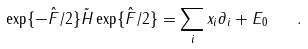<formula> <loc_0><loc_0><loc_500><loc_500>\exp \{ - \hat { F } / 2 \} \tilde { H } \exp \{ \hat { F } / 2 \} = \sum _ { i } x _ { i } \partial _ { i } + E _ { 0 } \quad .</formula> 